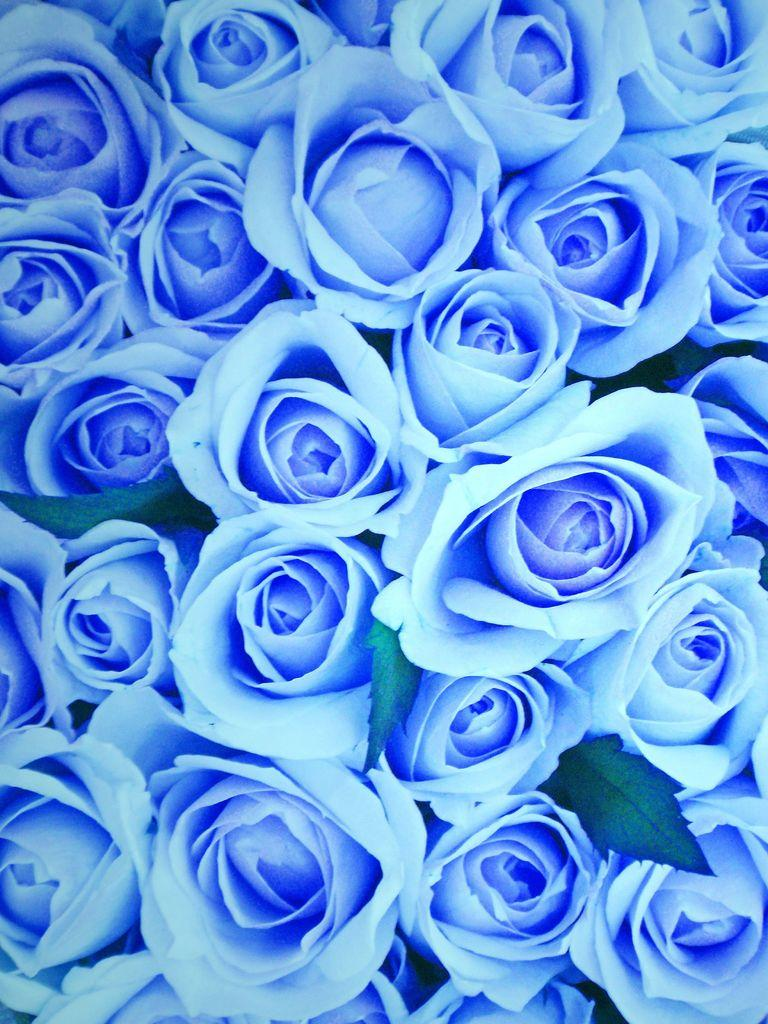What type of flowers are present in the image? There are blue roses in the image. What type of spy equipment can be seen in the image? There is no spy equipment present in the image; it features blue roses. What type of self-care activity is being performed in the image? There is no self-care activity present in the image; it features blue roses. 